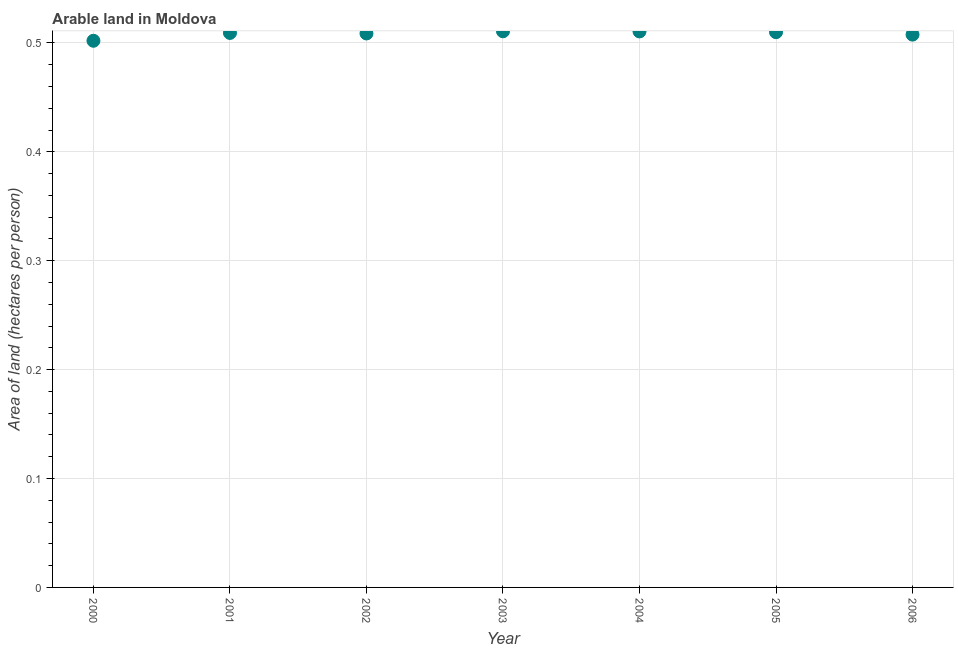What is the area of arable land in 2000?
Keep it short and to the point. 0.5. Across all years, what is the maximum area of arable land?
Your answer should be compact. 0.51. Across all years, what is the minimum area of arable land?
Provide a short and direct response. 0.5. In which year was the area of arable land maximum?
Give a very brief answer. 2003. What is the sum of the area of arable land?
Make the answer very short. 3.56. What is the difference between the area of arable land in 2001 and 2003?
Your answer should be very brief. -0. What is the average area of arable land per year?
Provide a succinct answer. 0.51. What is the median area of arable land?
Your answer should be very brief. 0.51. What is the ratio of the area of arable land in 2000 to that in 2001?
Provide a short and direct response. 0.99. Is the area of arable land in 2001 less than that in 2002?
Your answer should be compact. No. Is the difference between the area of arable land in 2005 and 2006 greater than the difference between any two years?
Provide a short and direct response. No. What is the difference between the highest and the second highest area of arable land?
Ensure brevity in your answer.  0. What is the difference between the highest and the lowest area of arable land?
Keep it short and to the point. 0.01. In how many years, is the area of arable land greater than the average area of arable land taken over all years?
Give a very brief answer. 5. How many dotlines are there?
Make the answer very short. 1. Are the values on the major ticks of Y-axis written in scientific E-notation?
Make the answer very short. No. Does the graph contain grids?
Your response must be concise. Yes. What is the title of the graph?
Provide a succinct answer. Arable land in Moldova. What is the label or title of the X-axis?
Ensure brevity in your answer.  Year. What is the label or title of the Y-axis?
Provide a succinct answer. Area of land (hectares per person). What is the Area of land (hectares per person) in 2000?
Your answer should be very brief. 0.5. What is the Area of land (hectares per person) in 2001?
Your answer should be very brief. 0.51. What is the Area of land (hectares per person) in 2002?
Your answer should be compact. 0.51. What is the Area of land (hectares per person) in 2003?
Provide a short and direct response. 0.51. What is the Area of land (hectares per person) in 2004?
Offer a terse response. 0.51. What is the Area of land (hectares per person) in 2005?
Ensure brevity in your answer.  0.51. What is the Area of land (hectares per person) in 2006?
Offer a terse response. 0.51. What is the difference between the Area of land (hectares per person) in 2000 and 2001?
Give a very brief answer. -0.01. What is the difference between the Area of land (hectares per person) in 2000 and 2002?
Make the answer very short. -0.01. What is the difference between the Area of land (hectares per person) in 2000 and 2003?
Provide a short and direct response. -0.01. What is the difference between the Area of land (hectares per person) in 2000 and 2004?
Provide a succinct answer. -0.01. What is the difference between the Area of land (hectares per person) in 2000 and 2005?
Keep it short and to the point. -0.01. What is the difference between the Area of land (hectares per person) in 2000 and 2006?
Your response must be concise. -0.01. What is the difference between the Area of land (hectares per person) in 2001 and 2002?
Ensure brevity in your answer.  0. What is the difference between the Area of land (hectares per person) in 2001 and 2003?
Your answer should be compact. -0. What is the difference between the Area of land (hectares per person) in 2001 and 2004?
Provide a short and direct response. -0. What is the difference between the Area of land (hectares per person) in 2001 and 2005?
Your answer should be compact. -0. What is the difference between the Area of land (hectares per person) in 2001 and 2006?
Make the answer very short. 0. What is the difference between the Area of land (hectares per person) in 2002 and 2003?
Provide a succinct answer. -0. What is the difference between the Area of land (hectares per person) in 2002 and 2004?
Ensure brevity in your answer.  -0. What is the difference between the Area of land (hectares per person) in 2002 and 2005?
Give a very brief answer. -0. What is the difference between the Area of land (hectares per person) in 2002 and 2006?
Your response must be concise. 0. What is the difference between the Area of land (hectares per person) in 2003 and 2004?
Your response must be concise. 0. What is the difference between the Area of land (hectares per person) in 2003 and 2005?
Ensure brevity in your answer.  0. What is the difference between the Area of land (hectares per person) in 2003 and 2006?
Your answer should be very brief. 0. What is the difference between the Area of land (hectares per person) in 2004 and 2005?
Provide a short and direct response. 0. What is the difference between the Area of land (hectares per person) in 2004 and 2006?
Provide a succinct answer. 0. What is the difference between the Area of land (hectares per person) in 2005 and 2006?
Give a very brief answer. 0. What is the ratio of the Area of land (hectares per person) in 2000 to that in 2001?
Provide a succinct answer. 0.99. What is the ratio of the Area of land (hectares per person) in 2000 to that in 2005?
Ensure brevity in your answer.  0.98. What is the ratio of the Area of land (hectares per person) in 2000 to that in 2006?
Your response must be concise. 0.99. What is the ratio of the Area of land (hectares per person) in 2001 to that in 2002?
Offer a very short reply. 1. What is the ratio of the Area of land (hectares per person) in 2001 to that in 2004?
Your answer should be compact. 1. What is the ratio of the Area of land (hectares per person) in 2001 to that in 2005?
Offer a very short reply. 1. What is the ratio of the Area of land (hectares per person) in 2001 to that in 2006?
Provide a succinct answer. 1. What is the ratio of the Area of land (hectares per person) in 2002 to that in 2005?
Your answer should be very brief. 1. What is the ratio of the Area of land (hectares per person) in 2003 to that in 2004?
Your answer should be very brief. 1. What is the ratio of the Area of land (hectares per person) in 2004 to that in 2005?
Offer a terse response. 1. 